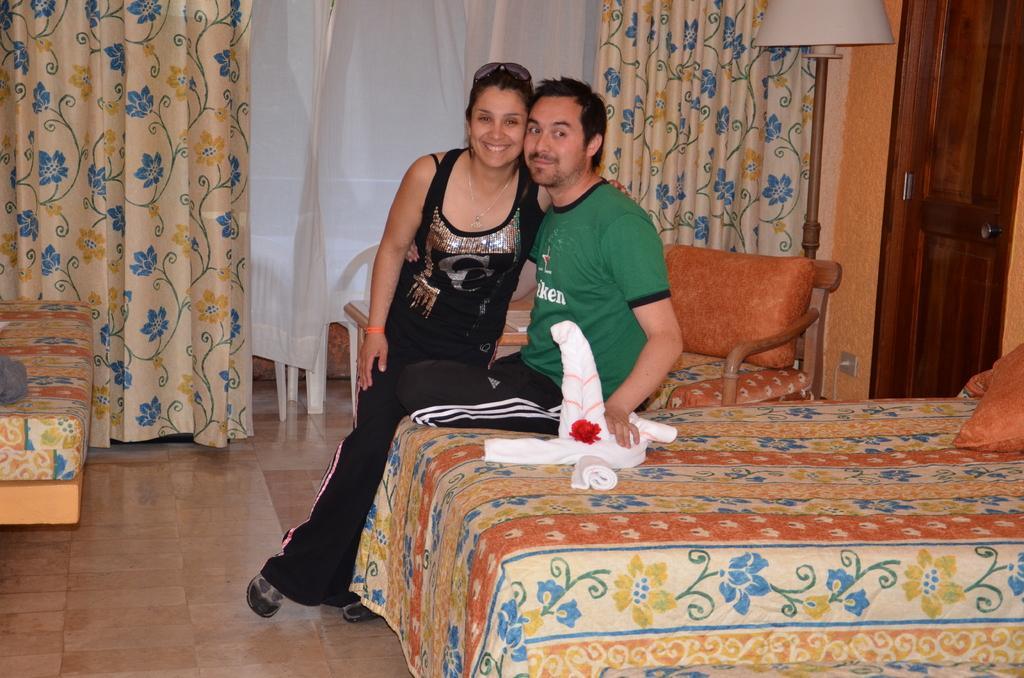Can you describe this image briefly? In this image I can see a man and a woman are sitting on a bed, I can also see smile on their faces. Here I can see few cushions on bed and in the background I can see a sofa, a chair, another bed and curtains. I can also see a lamp. 